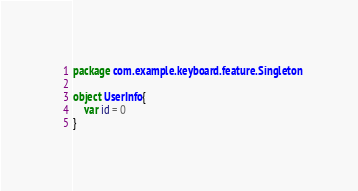<code> <loc_0><loc_0><loc_500><loc_500><_Kotlin_>package com.example.keyboard.feature.Singleton

object UserInfo{
    var id = 0
}</code> 